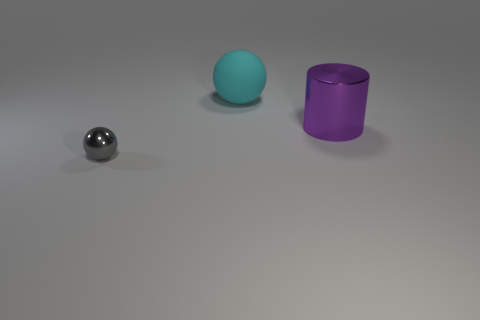Add 3 gray spheres. How many objects exist? 6 Subtract all cyan balls. How many balls are left? 1 Subtract all spheres. How many objects are left? 1 Add 3 purple cylinders. How many purple cylinders are left? 4 Add 2 tiny metal balls. How many tiny metal balls exist? 3 Subtract 0 purple blocks. How many objects are left? 3 Subtract 1 balls. How many balls are left? 1 Subtract all green spheres. Subtract all cyan cubes. How many spheres are left? 2 Subtract all tiny matte objects. Subtract all metal spheres. How many objects are left? 2 